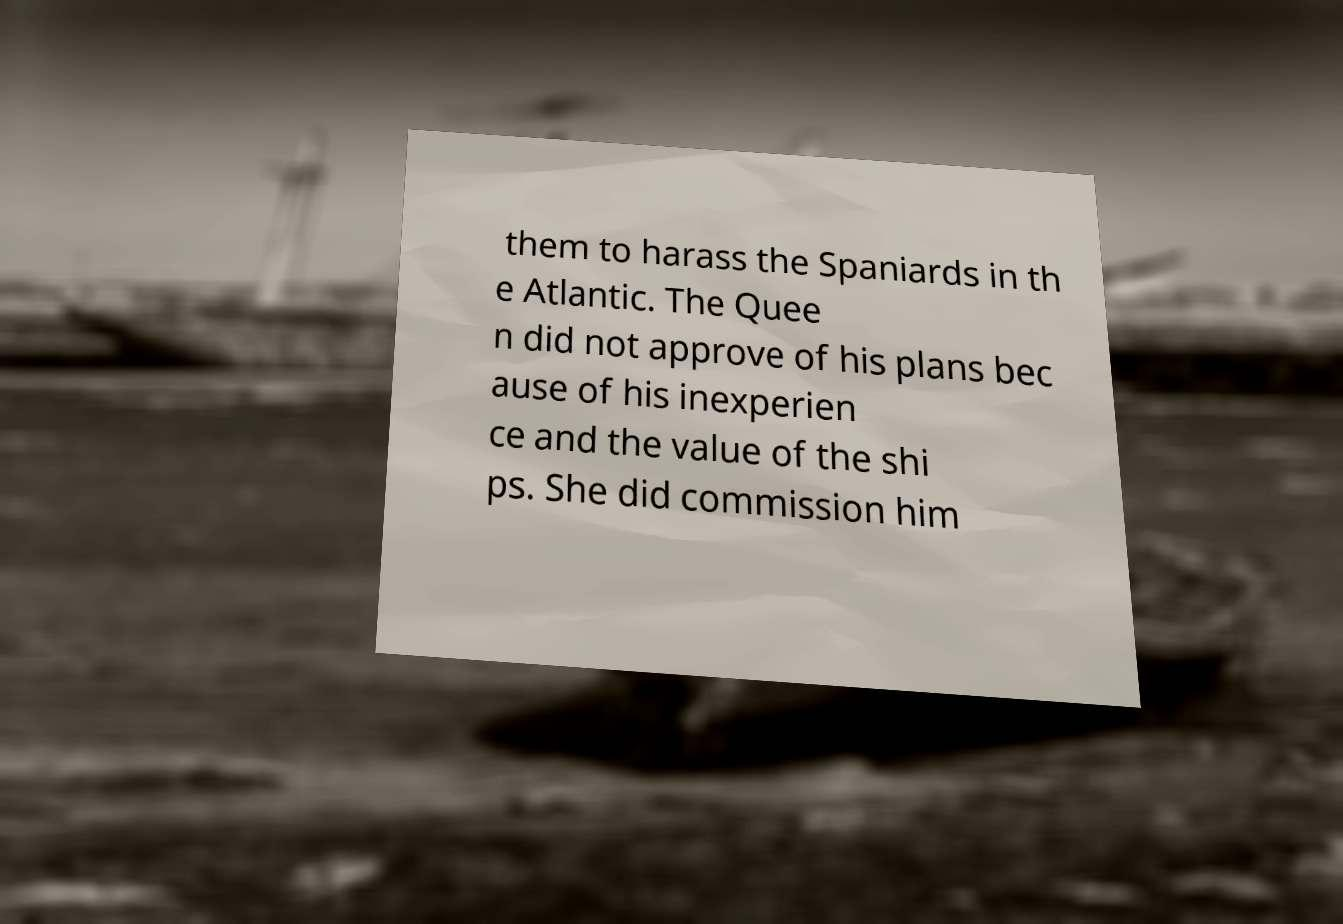I need the written content from this picture converted into text. Can you do that? them to harass the Spaniards in th e Atlantic. The Quee n did not approve of his plans bec ause of his inexperien ce and the value of the shi ps. She did commission him 